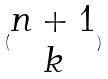Convert formula to latex. <formula><loc_0><loc_0><loc_500><loc_500>( \begin{matrix} n + 1 \\ k \end{matrix} )</formula> 